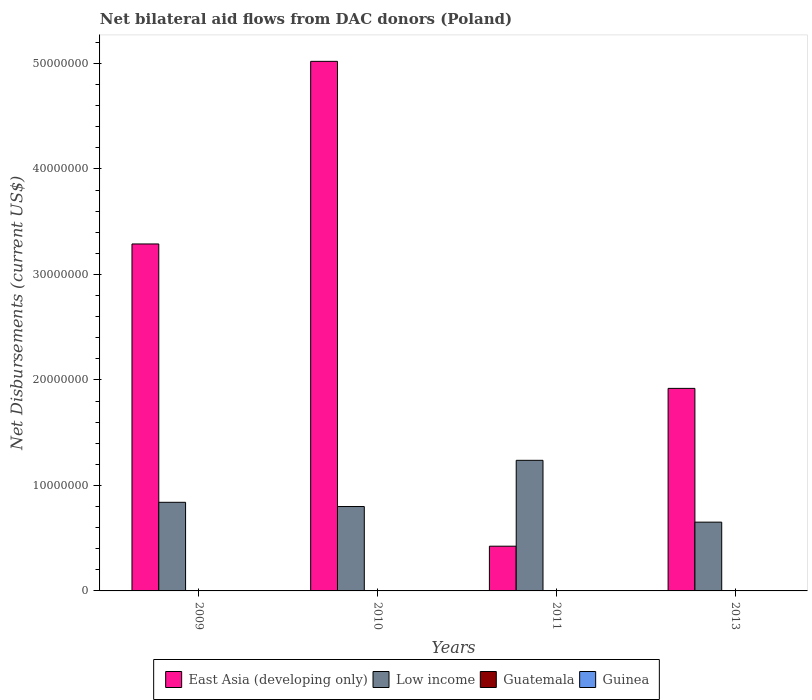Are the number of bars on each tick of the X-axis equal?
Your response must be concise. Yes. How many bars are there on the 1st tick from the right?
Offer a terse response. 4. What is the label of the 1st group of bars from the left?
Offer a terse response. 2009. What is the net bilateral aid flows in East Asia (developing only) in 2010?
Your response must be concise. 5.02e+07. Across all years, what is the maximum net bilateral aid flows in Guinea?
Your response must be concise. 3.00e+04. In which year was the net bilateral aid flows in Guatemala maximum?
Make the answer very short. 2011. In which year was the net bilateral aid flows in Guatemala minimum?
Provide a short and direct response. 2009. What is the total net bilateral aid flows in East Asia (developing only) in the graph?
Your answer should be compact. 1.07e+08. What is the difference between the net bilateral aid flows in East Asia (developing only) in 2009 and that in 2013?
Make the answer very short. 1.37e+07. What is the difference between the net bilateral aid flows in Guinea in 2011 and the net bilateral aid flows in East Asia (developing only) in 2009?
Make the answer very short. -3.29e+07. What is the average net bilateral aid flows in Guatemala per year?
Offer a terse response. 1.25e+04. In the year 2010, what is the difference between the net bilateral aid flows in Guinea and net bilateral aid flows in East Asia (developing only)?
Keep it short and to the point. -5.02e+07. In how many years, is the net bilateral aid flows in Guatemala greater than 50000000 US$?
Give a very brief answer. 0. What is the ratio of the net bilateral aid flows in East Asia (developing only) in 2009 to that in 2013?
Give a very brief answer. 1.71. Is the difference between the net bilateral aid flows in Guinea in 2010 and 2011 greater than the difference between the net bilateral aid flows in East Asia (developing only) in 2010 and 2011?
Provide a short and direct response. No. What is the difference between the highest and the second highest net bilateral aid flows in Guatemala?
Provide a short and direct response. 10000. What is the difference between the highest and the lowest net bilateral aid flows in Guatemala?
Keep it short and to the point. 10000. Is the sum of the net bilateral aid flows in Guinea in 2009 and 2013 greater than the maximum net bilateral aid flows in Low income across all years?
Your response must be concise. No. Is it the case that in every year, the sum of the net bilateral aid flows in Guatemala and net bilateral aid flows in East Asia (developing only) is greater than the sum of net bilateral aid flows in Low income and net bilateral aid flows in Guinea?
Give a very brief answer. No. What does the 3rd bar from the left in 2009 represents?
Your response must be concise. Guatemala. What does the 1st bar from the right in 2013 represents?
Offer a terse response. Guinea. Is it the case that in every year, the sum of the net bilateral aid flows in Guatemala and net bilateral aid flows in Guinea is greater than the net bilateral aid flows in East Asia (developing only)?
Give a very brief answer. No. How many bars are there?
Ensure brevity in your answer.  16. Are all the bars in the graph horizontal?
Offer a very short reply. No. How many years are there in the graph?
Provide a succinct answer. 4. What is the difference between two consecutive major ticks on the Y-axis?
Provide a short and direct response. 1.00e+07. Does the graph contain any zero values?
Make the answer very short. No. Does the graph contain grids?
Your response must be concise. No. How are the legend labels stacked?
Make the answer very short. Horizontal. What is the title of the graph?
Give a very brief answer. Net bilateral aid flows from DAC donors (Poland). Does "Chad" appear as one of the legend labels in the graph?
Your answer should be compact. No. What is the label or title of the X-axis?
Make the answer very short. Years. What is the label or title of the Y-axis?
Provide a short and direct response. Net Disbursements (current US$). What is the Net Disbursements (current US$) in East Asia (developing only) in 2009?
Provide a succinct answer. 3.29e+07. What is the Net Disbursements (current US$) of Low income in 2009?
Give a very brief answer. 8.40e+06. What is the Net Disbursements (current US$) of East Asia (developing only) in 2010?
Make the answer very short. 5.02e+07. What is the Net Disbursements (current US$) of Low income in 2010?
Your response must be concise. 8.00e+06. What is the Net Disbursements (current US$) in East Asia (developing only) in 2011?
Your response must be concise. 4.24e+06. What is the Net Disbursements (current US$) in Low income in 2011?
Your response must be concise. 1.24e+07. What is the Net Disbursements (current US$) of Guatemala in 2011?
Ensure brevity in your answer.  2.00e+04. What is the Net Disbursements (current US$) in East Asia (developing only) in 2013?
Offer a very short reply. 1.92e+07. What is the Net Disbursements (current US$) in Low income in 2013?
Your answer should be very brief. 6.52e+06. Across all years, what is the maximum Net Disbursements (current US$) of East Asia (developing only)?
Provide a succinct answer. 5.02e+07. Across all years, what is the maximum Net Disbursements (current US$) in Low income?
Provide a succinct answer. 1.24e+07. Across all years, what is the minimum Net Disbursements (current US$) in East Asia (developing only)?
Offer a terse response. 4.24e+06. Across all years, what is the minimum Net Disbursements (current US$) in Low income?
Ensure brevity in your answer.  6.52e+06. Across all years, what is the minimum Net Disbursements (current US$) in Guatemala?
Your answer should be very brief. 10000. Across all years, what is the minimum Net Disbursements (current US$) of Guinea?
Ensure brevity in your answer.  10000. What is the total Net Disbursements (current US$) of East Asia (developing only) in the graph?
Your response must be concise. 1.07e+08. What is the total Net Disbursements (current US$) in Low income in the graph?
Provide a succinct answer. 3.53e+07. What is the total Net Disbursements (current US$) of Guinea in the graph?
Provide a short and direct response. 6.00e+04. What is the difference between the Net Disbursements (current US$) of East Asia (developing only) in 2009 and that in 2010?
Your response must be concise. -1.73e+07. What is the difference between the Net Disbursements (current US$) of Low income in 2009 and that in 2010?
Ensure brevity in your answer.  4.00e+05. What is the difference between the Net Disbursements (current US$) of Guatemala in 2009 and that in 2010?
Your answer should be very brief. 0. What is the difference between the Net Disbursements (current US$) in East Asia (developing only) in 2009 and that in 2011?
Keep it short and to the point. 2.86e+07. What is the difference between the Net Disbursements (current US$) of Low income in 2009 and that in 2011?
Offer a very short reply. -3.98e+06. What is the difference between the Net Disbursements (current US$) in Guatemala in 2009 and that in 2011?
Offer a very short reply. -10000. What is the difference between the Net Disbursements (current US$) in Guinea in 2009 and that in 2011?
Your response must be concise. 0. What is the difference between the Net Disbursements (current US$) of East Asia (developing only) in 2009 and that in 2013?
Make the answer very short. 1.37e+07. What is the difference between the Net Disbursements (current US$) in Low income in 2009 and that in 2013?
Your response must be concise. 1.88e+06. What is the difference between the Net Disbursements (current US$) in Guatemala in 2009 and that in 2013?
Your answer should be very brief. 0. What is the difference between the Net Disbursements (current US$) in Guinea in 2009 and that in 2013?
Provide a succinct answer. 0. What is the difference between the Net Disbursements (current US$) of East Asia (developing only) in 2010 and that in 2011?
Your answer should be very brief. 4.60e+07. What is the difference between the Net Disbursements (current US$) in Low income in 2010 and that in 2011?
Your answer should be very brief. -4.38e+06. What is the difference between the Net Disbursements (current US$) of East Asia (developing only) in 2010 and that in 2013?
Ensure brevity in your answer.  3.10e+07. What is the difference between the Net Disbursements (current US$) in Low income in 2010 and that in 2013?
Your response must be concise. 1.48e+06. What is the difference between the Net Disbursements (current US$) of Guinea in 2010 and that in 2013?
Offer a terse response. 2.00e+04. What is the difference between the Net Disbursements (current US$) in East Asia (developing only) in 2011 and that in 2013?
Keep it short and to the point. -1.50e+07. What is the difference between the Net Disbursements (current US$) in Low income in 2011 and that in 2013?
Your response must be concise. 5.86e+06. What is the difference between the Net Disbursements (current US$) of Guatemala in 2011 and that in 2013?
Provide a short and direct response. 10000. What is the difference between the Net Disbursements (current US$) of East Asia (developing only) in 2009 and the Net Disbursements (current US$) of Low income in 2010?
Make the answer very short. 2.49e+07. What is the difference between the Net Disbursements (current US$) in East Asia (developing only) in 2009 and the Net Disbursements (current US$) in Guatemala in 2010?
Offer a terse response. 3.29e+07. What is the difference between the Net Disbursements (current US$) of East Asia (developing only) in 2009 and the Net Disbursements (current US$) of Guinea in 2010?
Your answer should be very brief. 3.29e+07. What is the difference between the Net Disbursements (current US$) of Low income in 2009 and the Net Disbursements (current US$) of Guatemala in 2010?
Offer a terse response. 8.39e+06. What is the difference between the Net Disbursements (current US$) in Low income in 2009 and the Net Disbursements (current US$) in Guinea in 2010?
Make the answer very short. 8.37e+06. What is the difference between the Net Disbursements (current US$) of East Asia (developing only) in 2009 and the Net Disbursements (current US$) of Low income in 2011?
Your response must be concise. 2.05e+07. What is the difference between the Net Disbursements (current US$) in East Asia (developing only) in 2009 and the Net Disbursements (current US$) in Guatemala in 2011?
Offer a very short reply. 3.29e+07. What is the difference between the Net Disbursements (current US$) in East Asia (developing only) in 2009 and the Net Disbursements (current US$) in Guinea in 2011?
Your answer should be compact. 3.29e+07. What is the difference between the Net Disbursements (current US$) in Low income in 2009 and the Net Disbursements (current US$) in Guatemala in 2011?
Your response must be concise. 8.38e+06. What is the difference between the Net Disbursements (current US$) of Low income in 2009 and the Net Disbursements (current US$) of Guinea in 2011?
Offer a very short reply. 8.39e+06. What is the difference between the Net Disbursements (current US$) of Guatemala in 2009 and the Net Disbursements (current US$) of Guinea in 2011?
Make the answer very short. 0. What is the difference between the Net Disbursements (current US$) of East Asia (developing only) in 2009 and the Net Disbursements (current US$) of Low income in 2013?
Give a very brief answer. 2.64e+07. What is the difference between the Net Disbursements (current US$) in East Asia (developing only) in 2009 and the Net Disbursements (current US$) in Guatemala in 2013?
Your answer should be very brief. 3.29e+07. What is the difference between the Net Disbursements (current US$) of East Asia (developing only) in 2009 and the Net Disbursements (current US$) of Guinea in 2013?
Make the answer very short. 3.29e+07. What is the difference between the Net Disbursements (current US$) in Low income in 2009 and the Net Disbursements (current US$) in Guatemala in 2013?
Your answer should be very brief. 8.39e+06. What is the difference between the Net Disbursements (current US$) in Low income in 2009 and the Net Disbursements (current US$) in Guinea in 2013?
Provide a succinct answer. 8.39e+06. What is the difference between the Net Disbursements (current US$) of East Asia (developing only) in 2010 and the Net Disbursements (current US$) of Low income in 2011?
Give a very brief answer. 3.78e+07. What is the difference between the Net Disbursements (current US$) in East Asia (developing only) in 2010 and the Net Disbursements (current US$) in Guatemala in 2011?
Make the answer very short. 5.02e+07. What is the difference between the Net Disbursements (current US$) of East Asia (developing only) in 2010 and the Net Disbursements (current US$) of Guinea in 2011?
Keep it short and to the point. 5.02e+07. What is the difference between the Net Disbursements (current US$) of Low income in 2010 and the Net Disbursements (current US$) of Guatemala in 2011?
Provide a succinct answer. 7.98e+06. What is the difference between the Net Disbursements (current US$) in Low income in 2010 and the Net Disbursements (current US$) in Guinea in 2011?
Give a very brief answer. 7.99e+06. What is the difference between the Net Disbursements (current US$) in East Asia (developing only) in 2010 and the Net Disbursements (current US$) in Low income in 2013?
Provide a short and direct response. 4.37e+07. What is the difference between the Net Disbursements (current US$) in East Asia (developing only) in 2010 and the Net Disbursements (current US$) in Guatemala in 2013?
Your response must be concise. 5.02e+07. What is the difference between the Net Disbursements (current US$) of East Asia (developing only) in 2010 and the Net Disbursements (current US$) of Guinea in 2013?
Keep it short and to the point. 5.02e+07. What is the difference between the Net Disbursements (current US$) of Low income in 2010 and the Net Disbursements (current US$) of Guatemala in 2013?
Provide a short and direct response. 7.99e+06. What is the difference between the Net Disbursements (current US$) in Low income in 2010 and the Net Disbursements (current US$) in Guinea in 2013?
Offer a very short reply. 7.99e+06. What is the difference between the Net Disbursements (current US$) in Guatemala in 2010 and the Net Disbursements (current US$) in Guinea in 2013?
Provide a succinct answer. 0. What is the difference between the Net Disbursements (current US$) of East Asia (developing only) in 2011 and the Net Disbursements (current US$) of Low income in 2013?
Keep it short and to the point. -2.28e+06. What is the difference between the Net Disbursements (current US$) in East Asia (developing only) in 2011 and the Net Disbursements (current US$) in Guatemala in 2013?
Ensure brevity in your answer.  4.23e+06. What is the difference between the Net Disbursements (current US$) in East Asia (developing only) in 2011 and the Net Disbursements (current US$) in Guinea in 2013?
Your answer should be very brief. 4.23e+06. What is the difference between the Net Disbursements (current US$) of Low income in 2011 and the Net Disbursements (current US$) of Guatemala in 2013?
Make the answer very short. 1.24e+07. What is the difference between the Net Disbursements (current US$) of Low income in 2011 and the Net Disbursements (current US$) of Guinea in 2013?
Your answer should be very brief. 1.24e+07. What is the average Net Disbursements (current US$) in East Asia (developing only) per year?
Your answer should be compact. 2.66e+07. What is the average Net Disbursements (current US$) of Low income per year?
Offer a very short reply. 8.82e+06. What is the average Net Disbursements (current US$) of Guatemala per year?
Ensure brevity in your answer.  1.25e+04. What is the average Net Disbursements (current US$) in Guinea per year?
Offer a very short reply. 1.50e+04. In the year 2009, what is the difference between the Net Disbursements (current US$) of East Asia (developing only) and Net Disbursements (current US$) of Low income?
Make the answer very short. 2.45e+07. In the year 2009, what is the difference between the Net Disbursements (current US$) in East Asia (developing only) and Net Disbursements (current US$) in Guatemala?
Ensure brevity in your answer.  3.29e+07. In the year 2009, what is the difference between the Net Disbursements (current US$) of East Asia (developing only) and Net Disbursements (current US$) of Guinea?
Make the answer very short. 3.29e+07. In the year 2009, what is the difference between the Net Disbursements (current US$) in Low income and Net Disbursements (current US$) in Guatemala?
Make the answer very short. 8.39e+06. In the year 2009, what is the difference between the Net Disbursements (current US$) of Low income and Net Disbursements (current US$) of Guinea?
Keep it short and to the point. 8.39e+06. In the year 2009, what is the difference between the Net Disbursements (current US$) in Guatemala and Net Disbursements (current US$) in Guinea?
Your response must be concise. 0. In the year 2010, what is the difference between the Net Disbursements (current US$) in East Asia (developing only) and Net Disbursements (current US$) in Low income?
Your answer should be compact. 4.22e+07. In the year 2010, what is the difference between the Net Disbursements (current US$) of East Asia (developing only) and Net Disbursements (current US$) of Guatemala?
Offer a very short reply. 5.02e+07. In the year 2010, what is the difference between the Net Disbursements (current US$) of East Asia (developing only) and Net Disbursements (current US$) of Guinea?
Your answer should be very brief. 5.02e+07. In the year 2010, what is the difference between the Net Disbursements (current US$) of Low income and Net Disbursements (current US$) of Guatemala?
Provide a short and direct response. 7.99e+06. In the year 2010, what is the difference between the Net Disbursements (current US$) in Low income and Net Disbursements (current US$) in Guinea?
Keep it short and to the point. 7.97e+06. In the year 2011, what is the difference between the Net Disbursements (current US$) in East Asia (developing only) and Net Disbursements (current US$) in Low income?
Offer a terse response. -8.14e+06. In the year 2011, what is the difference between the Net Disbursements (current US$) in East Asia (developing only) and Net Disbursements (current US$) in Guatemala?
Make the answer very short. 4.22e+06. In the year 2011, what is the difference between the Net Disbursements (current US$) in East Asia (developing only) and Net Disbursements (current US$) in Guinea?
Offer a terse response. 4.23e+06. In the year 2011, what is the difference between the Net Disbursements (current US$) in Low income and Net Disbursements (current US$) in Guatemala?
Your response must be concise. 1.24e+07. In the year 2011, what is the difference between the Net Disbursements (current US$) of Low income and Net Disbursements (current US$) of Guinea?
Offer a very short reply. 1.24e+07. In the year 2013, what is the difference between the Net Disbursements (current US$) of East Asia (developing only) and Net Disbursements (current US$) of Low income?
Offer a very short reply. 1.27e+07. In the year 2013, what is the difference between the Net Disbursements (current US$) of East Asia (developing only) and Net Disbursements (current US$) of Guatemala?
Keep it short and to the point. 1.92e+07. In the year 2013, what is the difference between the Net Disbursements (current US$) in East Asia (developing only) and Net Disbursements (current US$) in Guinea?
Give a very brief answer. 1.92e+07. In the year 2013, what is the difference between the Net Disbursements (current US$) in Low income and Net Disbursements (current US$) in Guatemala?
Provide a short and direct response. 6.51e+06. In the year 2013, what is the difference between the Net Disbursements (current US$) of Low income and Net Disbursements (current US$) of Guinea?
Your answer should be very brief. 6.51e+06. In the year 2013, what is the difference between the Net Disbursements (current US$) in Guatemala and Net Disbursements (current US$) in Guinea?
Give a very brief answer. 0. What is the ratio of the Net Disbursements (current US$) in East Asia (developing only) in 2009 to that in 2010?
Offer a terse response. 0.66. What is the ratio of the Net Disbursements (current US$) of Low income in 2009 to that in 2010?
Your answer should be very brief. 1.05. What is the ratio of the Net Disbursements (current US$) of Guinea in 2009 to that in 2010?
Your answer should be very brief. 0.33. What is the ratio of the Net Disbursements (current US$) of East Asia (developing only) in 2009 to that in 2011?
Offer a very short reply. 7.76. What is the ratio of the Net Disbursements (current US$) in Low income in 2009 to that in 2011?
Provide a short and direct response. 0.68. What is the ratio of the Net Disbursements (current US$) in Guatemala in 2009 to that in 2011?
Your response must be concise. 0.5. What is the ratio of the Net Disbursements (current US$) in Guinea in 2009 to that in 2011?
Ensure brevity in your answer.  1. What is the ratio of the Net Disbursements (current US$) of East Asia (developing only) in 2009 to that in 2013?
Your answer should be compact. 1.71. What is the ratio of the Net Disbursements (current US$) in Low income in 2009 to that in 2013?
Your answer should be compact. 1.29. What is the ratio of the Net Disbursements (current US$) in Guatemala in 2009 to that in 2013?
Provide a short and direct response. 1. What is the ratio of the Net Disbursements (current US$) in East Asia (developing only) in 2010 to that in 2011?
Your response must be concise. 11.84. What is the ratio of the Net Disbursements (current US$) in Low income in 2010 to that in 2011?
Your response must be concise. 0.65. What is the ratio of the Net Disbursements (current US$) of Guatemala in 2010 to that in 2011?
Offer a very short reply. 0.5. What is the ratio of the Net Disbursements (current US$) of East Asia (developing only) in 2010 to that in 2013?
Your answer should be very brief. 2.61. What is the ratio of the Net Disbursements (current US$) of Low income in 2010 to that in 2013?
Offer a terse response. 1.23. What is the ratio of the Net Disbursements (current US$) of Guatemala in 2010 to that in 2013?
Your answer should be very brief. 1. What is the ratio of the Net Disbursements (current US$) in Guinea in 2010 to that in 2013?
Offer a very short reply. 3. What is the ratio of the Net Disbursements (current US$) of East Asia (developing only) in 2011 to that in 2013?
Keep it short and to the point. 0.22. What is the ratio of the Net Disbursements (current US$) of Low income in 2011 to that in 2013?
Offer a terse response. 1.9. What is the ratio of the Net Disbursements (current US$) in Guatemala in 2011 to that in 2013?
Keep it short and to the point. 2. What is the difference between the highest and the second highest Net Disbursements (current US$) in East Asia (developing only)?
Provide a short and direct response. 1.73e+07. What is the difference between the highest and the second highest Net Disbursements (current US$) of Low income?
Ensure brevity in your answer.  3.98e+06. What is the difference between the highest and the second highest Net Disbursements (current US$) in Guinea?
Your answer should be very brief. 2.00e+04. What is the difference between the highest and the lowest Net Disbursements (current US$) of East Asia (developing only)?
Keep it short and to the point. 4.60e+07. What is the difference between the highest and the lowest Net Disbursements (current US$) in Low income?
Offer a very short reply. 5.86e+06. What is the difference between the highest and the lowest Net Disbursements (current US$) in Guatemala?
Give a very brief answer. 10000. What is the difference between the highest and the lowest Net Disbursements (current US$) of Guinea?
Your answer should be compact. 2.00e+04. 